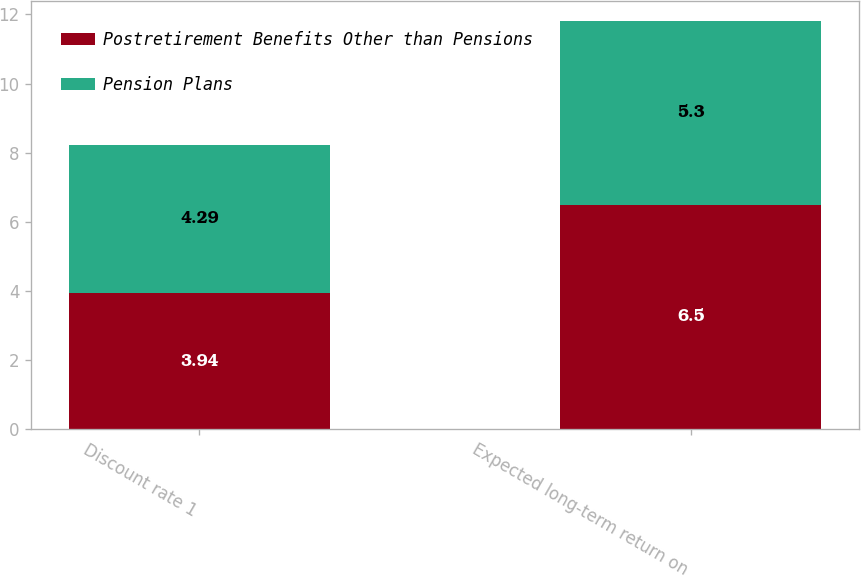<chart> <loc_0><loc_0><loc_500><loc_500><stacked_bar_chart><ecel><fcel>Discount rate 1<fcel>Expected long-term return on<nl><fcel>Postretirement Benefits Other than Pensions<fcel>3.94<fcel>6.5<nl><fcel>Pension Plans<fcel>4.29<fcel>5.3<nl></chart> 